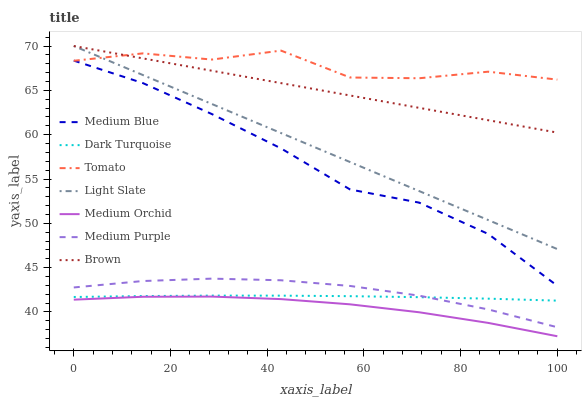Does Medium Orchid have the minimum area under the curve?
Answer yes or no. Yes. Does Tomato have the maximum area under the curve?
Answer yes or no. Yes. Does Brown have the minimum area under the curve?
Answer yes or no. No. Does Brown have the maximum area under the curve?
Answer yes or no. No. Is Light Slate the smoothest?
Answer yes or no. Yes. Is Tomato the roughest?
Answer yes or no. Yes. Is Brown the smoothest?
Answer yes or no. No. Is Brown the roughest?
Answer yes or no. No. Does Medium Orchid have the lowest value?
Answer yes or no. Yes. Does Brown have the lowest value?
Answer yes or no. No. Does Light Slate have the highest value?
Answer yes or no. Yes. Does Dark Turquoise have the highest value?
Answer yes or no. No. Is Dark Turquoise less than Medium Blue?
Answer yes or no. Yes. Is Brown greater than Dark Turquoise?
Answer yes or no. Yes. Does Tomato intersect Light Slate?
Answer yes or no. Yes. Is Tomato less than Light Slate?
Answer yes or no. No. Is Tomato greater than Light Slate?
Answer yes or no. No. Does Dark Turquoise intersect Medium Blue?
Answer yes or no. No. 